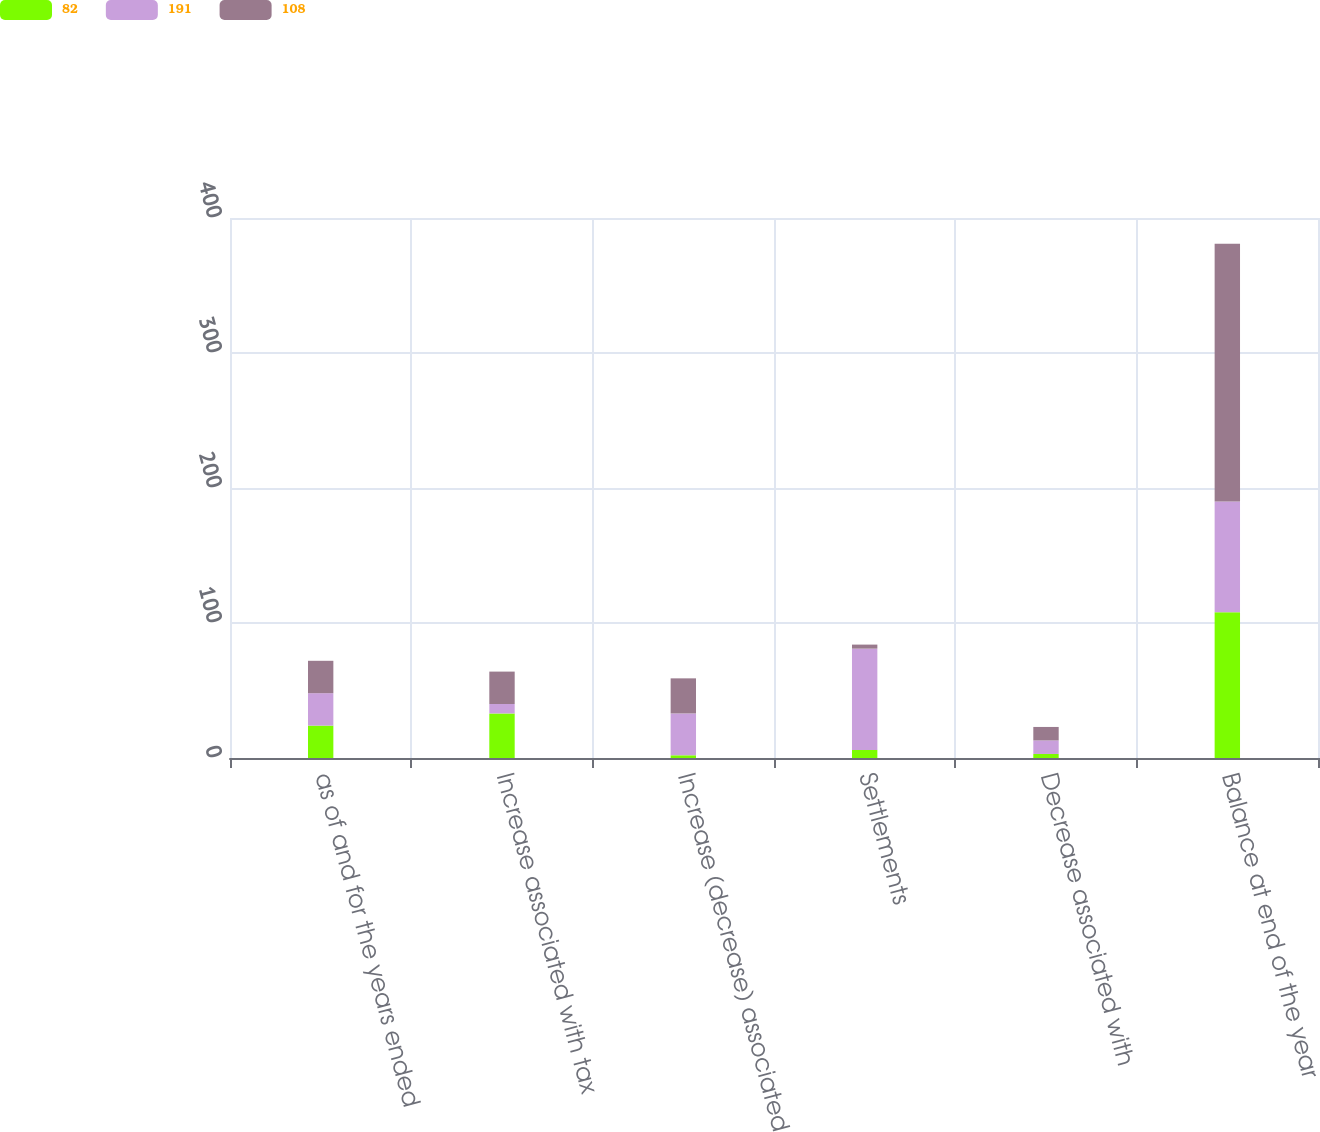Convert chart to OTSL. <chart><loc_0><loc_0><loc_500><loc_500><stacked_bar_chart><ecel><fcel>as of and for the years ended<fcel>Increase associated with tax<fcel>Increase (decrease) associated<fcel>Settlements<fcel>Decrease associated with<fcel>Balance at end of the year<nl><fcel>82<fcel>24<fcel>33<fcel>2<fcel>6<fcel>3<fcel>108<nl><fcel>191<fcel>24<fcel>7<fcel>31<fcel>75<fcel>10<fcel>82<nl><fcel>108<fcel>24<fcel>24<fcel>26<fcel>3<fcel>10<fcel>191<nl></chart> 